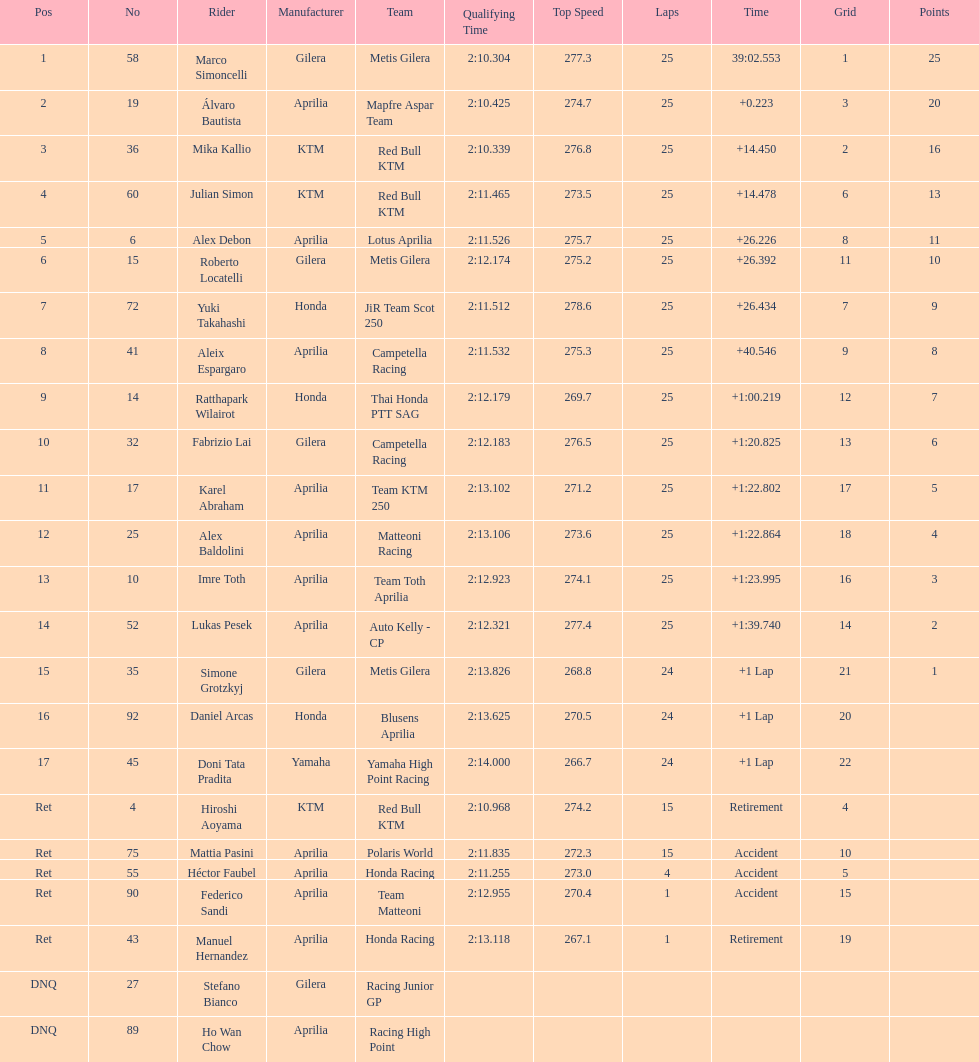Could you help me parse every detail presented in this table? {'header': ['Pos', 'No', 'Rider', 'Manufacturer', 'Team', 'Qualifying Time', 'Top Speed', 'Laps', 'Time', 'Grid', 'Points'], 'rows': [['1', '58', 'Marco Simoncelli', 'Gilera', 'Metis Gilera', '2:10.304', '277.3', '25', '39:02.553', '1', '25'], ['2', '19', 'Álvaro Bautista', 'Aprilia', 'Mapfre Aspar Team', '2:10.425', '274.7', '25', '+0.223', '3', '20'], ['3', '36', 'Mika Kallio', 'KTM', 'Red Bull KTM', '2:10.339', '276.8', '25', '+14.450', '2', '16'], ['4', '60', 'Julian Simon', 'KTM', 'Red Bull KTM', '2:11.465', '273.5', '25', '+14.478', '6', '13'], ['5', '6', 'Alex Debon', 'Aprilia', 'Lotus Aprilia', '2:11.526', '275.7', '25', '+26.226', '8', '11'], ['6', '15', 'Roberto Locatelli', 'Gilera', 'Metis Gilera', '2:12.174', '275.2', '25', '+26.392', '11', '10'], ['7', '72', 'Yuki Takahashi', 'Honda', 'JiR Team Scot 250', '2:11.512', '278.6', '25', '+26.434', '7', '9'], ['8', '41', 'Aleix Espargaro', 'Aprilia', 'Campetella Racing', '2:11.532', '275.3', '25', '+40.546', '9', '8'], ['9', '14', 'Ratthapark Wilairot', 'Honda', 'Thai Honda PTT SAG', '2:12.179', '269.7', '25', '+1:00.219', '12', '7'], ['10', '32', 'Fabrizio Lai', 'Gilera', 'Campetella Racing', '2:12.183', '276.5', '25', '+1:20.825', '13', '6'], ['11', '17', 'Karel Abraham', 'Aprilia', 'Team KTM 250', '2:13.102', '271.2', '25', '+1:22.802', '17', '5'], ['12', '25', 'Alex Baldolini', 'Aprilia', 'Matteoni Racing', '2:13.106', '273.6', '25', '+1:22.864', '18', '4'], ['13', '10', 'Imre Toth', 'Aprilia', 'Team Toth Aprilia', '2:12.923', '274.1', '25', '+1:23.995', '16', '3'], ['14', '52', 'Lukas Pesek', 'Aprilia', 'Auto Kelly - CP', '2:12.321', '277.4', '25', '+1:39.740', '14', '2'], ['15', '35', 'Simone Grotzkyj', 'Gilera', 'Metis Gilera', '2:13.826', '268.8', '24', '+1 Lap', '21', '1'], ['16', '92', 'Daniel Arcas', 'Honda', 'Blusens Aprilia', '2:13.625', '270.5', '24', '+1 Lap', '20', ''], ['17', '45', 'Doni Tata Pradita', 'Yamaha', 'Yamaha High Point Racing', '2:14.000', '266.7', '24', '+1 Lap', '22', ''], ['Ret', '4', 'Hiroshi Aoyama', 'KTM', 'Red Bull KTM', '2:10.968', '274.2', '15', 'Retirement', '4', ''], ['Ret', '75', 'Mattia Pasini', 'Aprilia', 'Polaris World', '2:11.835', '272.3', '15', 'Accident', '10', ''], ['Ret', '55', 'Héctor Faubel', 'Aprilia', 'Honda Racing', '2:11.255', '273.0', '4', 'Accident', '5', ''], ['Ret', '90', 'Federico Sandi', 'Aprilia', 'Team Matteoni', '2:12.955', '270.4', '1', 'Accident', '15', ''], ['Ret', '43', 'Manuel Hernandez', 'Aprilia', 'Honda Racing', '2:13.118', '267.1', '1', 'Retirement', '19', ''], ['DNQ', '27', 'Stefano Bianco', 'Gilera', 'Racing Junior GP', '', '', '', '', '', ''], ['DNQ', '89', 'Ho Wan Chow', 'Aprilia', 'Racing High Point', '', '', '', '', '', '']]} The country with the most riders was Italy. 